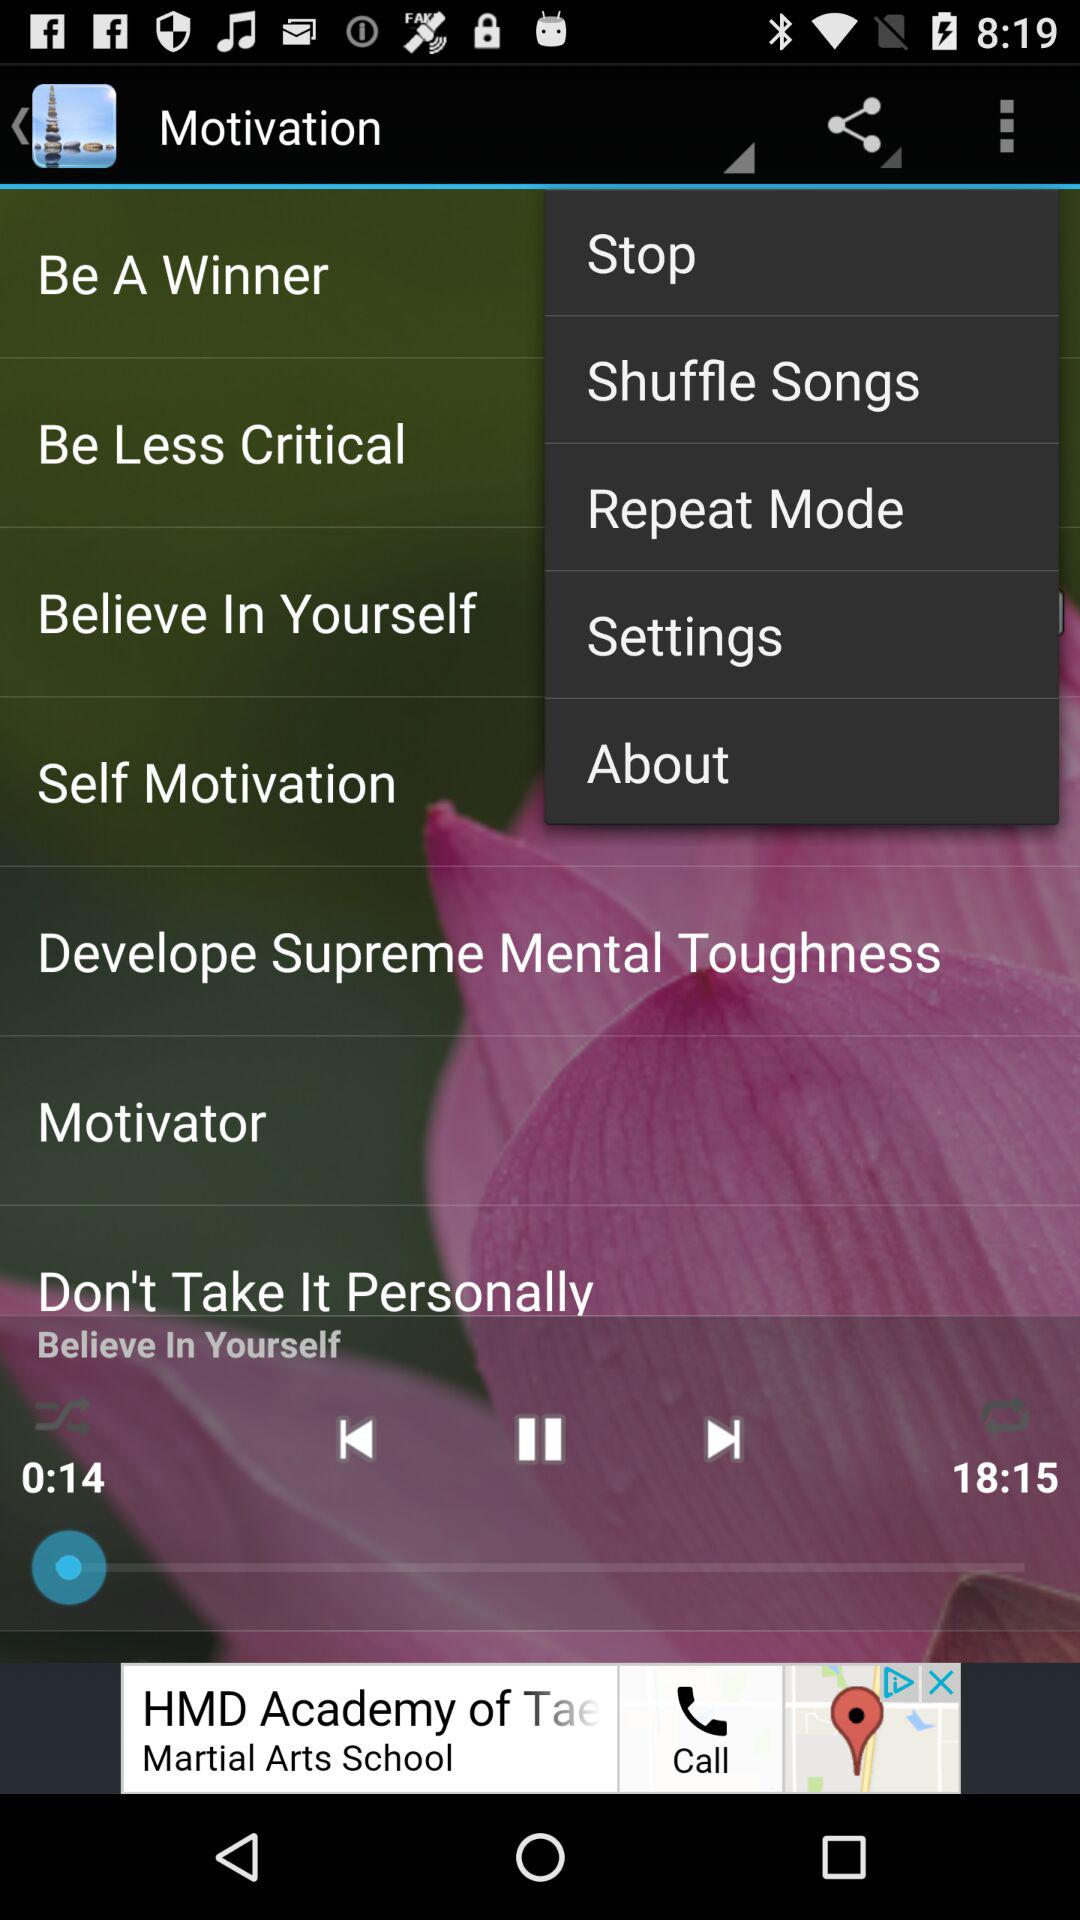What is the total time duration for the song playing in the player? The total time duration is 18:15. 